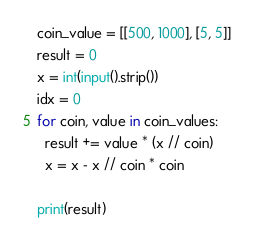Convert code to text. <code><loc_0><loc_0><loc_500><loc_500><_Python_>coin_value = [[500, 1000], [5, 5]]
result = 0
x = int(input().strip())
idx = 0
for coin, value in coin_values:
  result += value * (x // coin)
  x = x - x // coin * coin
  
print(result)</code> 